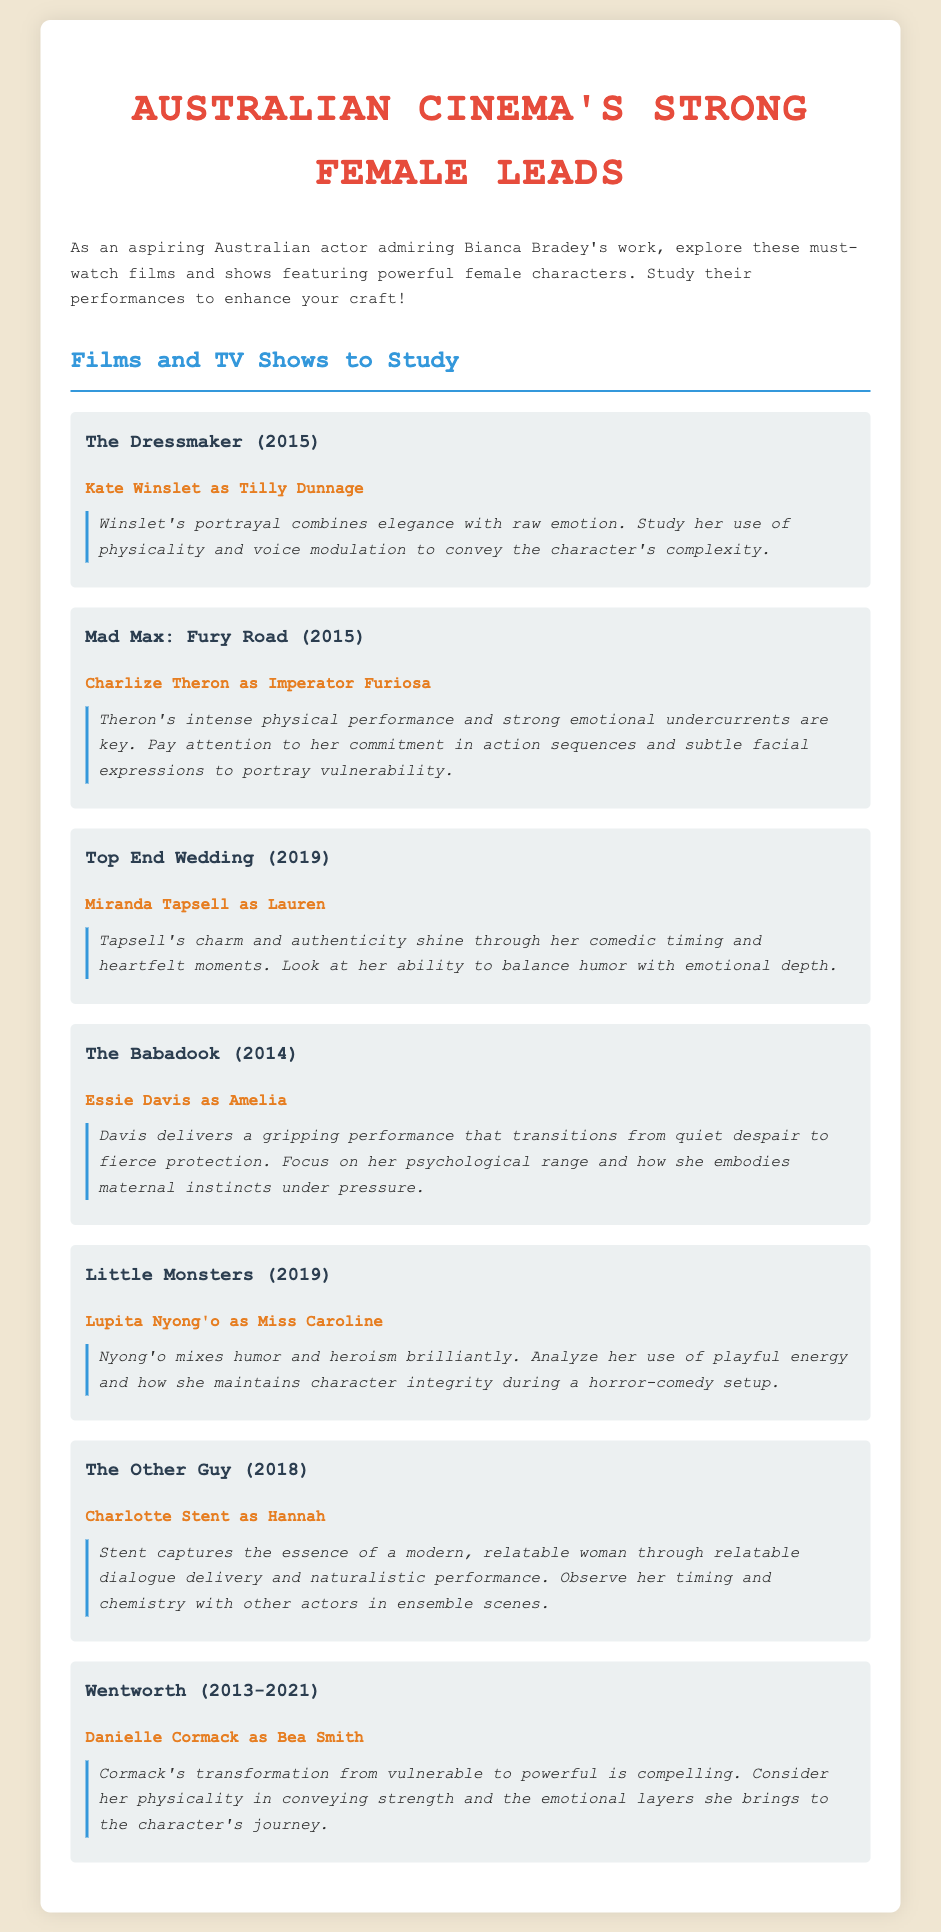What is the title of the film featuring Kate Winslet? The title of the film featuring Kate Winslet is provided under her name in the document.
Answer: The Dressmaker Who plays the lead role in Mad Max: Fury Road? The document contains the lead actress’s name associated with the film Mad Max: Fury Road.
Answer: Charlize Theron What is the release year of Top End Wedding? The year when Top End Wedding was released is noted in the document.
Answer: 2019 What performance style is highlighted for Essie Davis in The Babadook? The document notes aspects of Essie Davis's performance style that are significant to her character portrayal.
Answer: Psychological range Which character does Danielle Cormack portray in Wentworth? The document specifies the name of the character that Danielle Cormack plays in the series Wentworth.
Answer: Bea Smith How many films and TV shows are listed in the document? By counting the entries in the list section, the total number of films and TV shows can be determined.
Answer: 7 